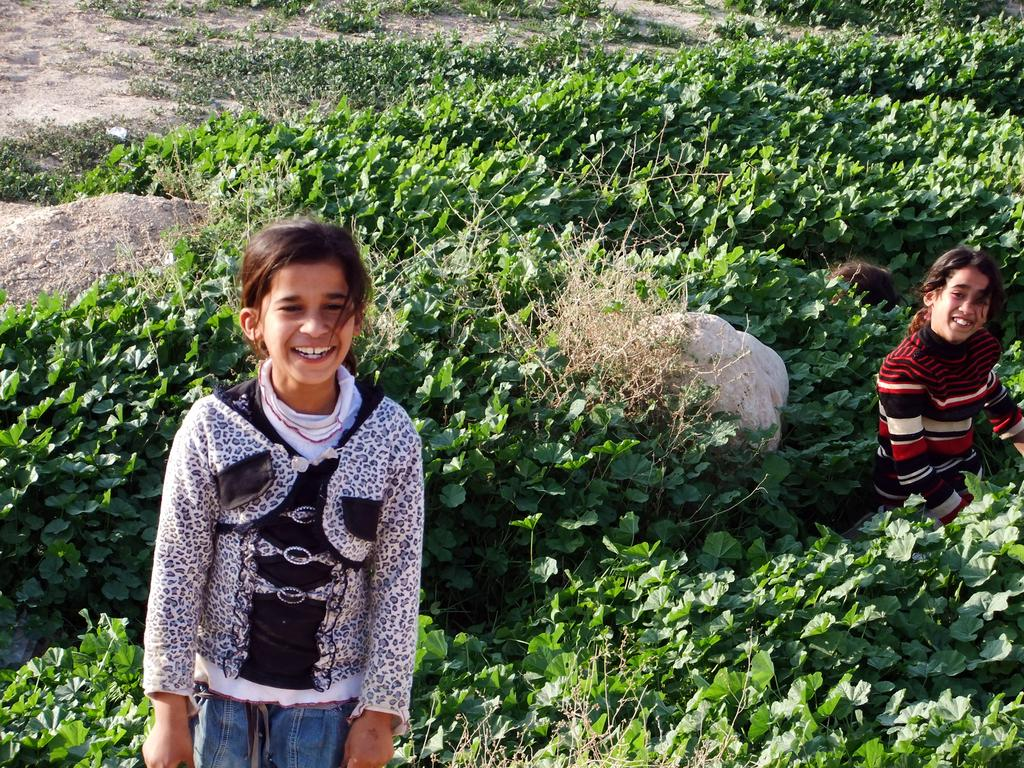Who is present in the image? There are children in the image. What are the children standing between? The children are standing between plants. What can be seen in the background of the image? There are rocks, plants, and the ground visible in the background of the image. Can you see any cobwebs in the image? There is no mention of cobwebs in the provided facts, so it cannot be determined if any are present in the image. How many girls are visible in the image? The provided facts do not specify the gender of the children, so it cannot be determined if any girls are visible in the image. 